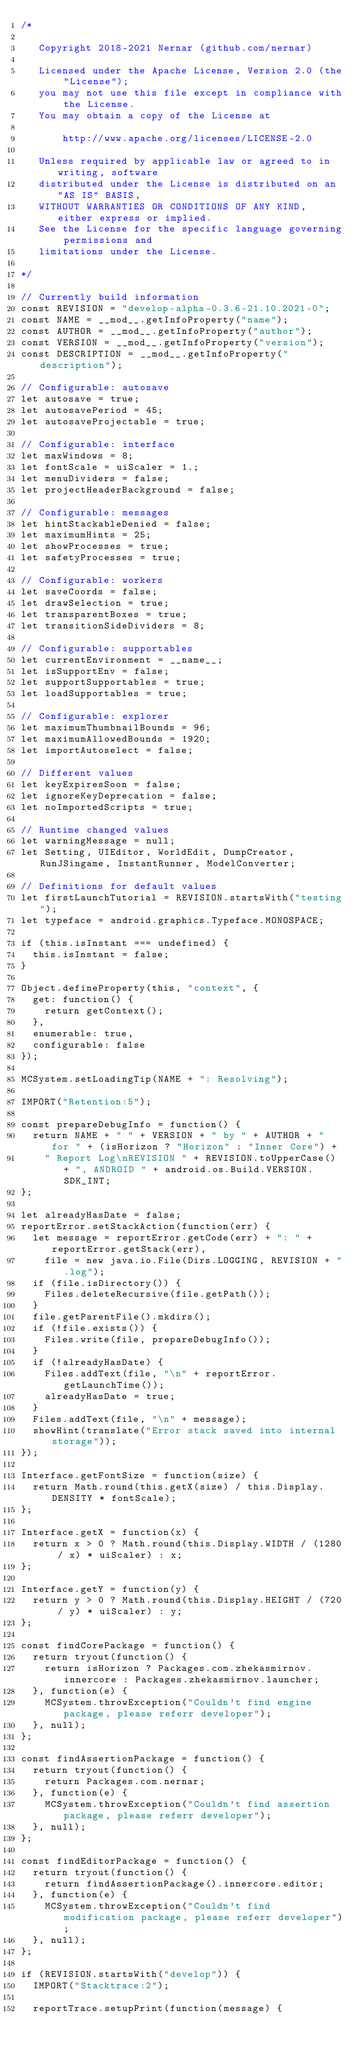<code> <loc_0><loc_0><loc_500><loc_500><_JavaScript_>/*

   Copyright 2018-2021 Nernar (github.com/nernar)
   
   Licensed under the Apache License, Version 2.0 (the "License");
   you may not use this file except in compliance with the License.
   You may obtain a copy of the License at
   
       http://www.apache.org/licenses/LICENSE-2.0
   
   Unless required by applicable law or agreed to in writing, software
   distributed under the License is distributed on an "AS IS" BASIS,
   WITHOUT WARRANTIES OR CONDITIONS OF ANY KIND, either express or implied.
   See the License for the specific language governing permissions and
   limitations under the License.

*/

// Currently build information
const REVISION = "develop-alpha-0.3.6-21.10.2021-0";
const NAME = __mod__.getInfoProperty("name");
const AUTHOR = __mod__.getInfoProperty("author");
const VERSION = __mod__.getInfoProperty("version");
const DESCRIPTION = __mod__.getInfoProperty("description");

// Configurable: autosave
let autosave = true;
let autosavePeriod = 45;
let autosaveProjectable = true;

// Configurable: interface
let maxWindows = 8;
let fontScale = uiScaler = 1.;
let menuDividers = false;
let projectHeaderBackground = false;

// Configurable: messages
let hintStackableDenied = false;
let maximumHints = 25;
let showProcesses = true;
let safetyProcesses = true;

// Configurable: workers
let saveCoords = false;
let drawSelection = true;
let transparentBoxes = true;
let transitionSideDividers = 8;

// Configurable: supportables
let currentEnvironment = __name__;
let isSupportEnv = false;
let supportSupportables = true;
let loadSupportables = true;

// Configurable: explorer
let maximumThumbnailBounds = 96;
let maximumAllowedBounds = 1920;
let importAutoselect = false;

// Different values
let keyExpiresSoon = false;
let ignoreKeyDeprecation = false;
let noImportedScripts = true;

// Runtime changed values
let warningMessage = null;
let Setting, UIEditor, WorldEdit, DumpCreator, RunJSingame, InstantRunner, ModelConverter;

// Definitions for default values
let firstLaunchTutorial = REVISION.startsWith("testing");
let typeface = android.graphics.Typeface.MONOSPACE;

if (this.isInstant === undefined) {
	this.isInstant = false;
}

Object.defineProperty(this, "context", {
	get: function() {
		return getContext();
	},
	enumerable: true,
	configurable: false
});

MCSystem.setLoadingTip(NAME + ": Resolving");

IMPORT("Retention:5");

const prepareDebugInfo = function() {
	return NAME + " " + VERSION + " by " + AUTHOR + " for " + (isHorizon ? "Horizon" : "Inner Core") +
		" Report Log\nREVISION " + REVISION.toUpperCase() + ", ANDROID " + android.os.Build.VERSION.SDK_INT;
};

let alreadyHasDate = false;
reportError.setStackAction(function(err) {
	let message = reportError.getCode(err) + ": " + reportError.getStack(err),
		file = new java.io.File(Dirs.LOGGING, REVISION + ".log");
	if (file.isDirectory()) {
		Files.deleteRecursive(file.getPath());
	}
	file.getParentFile().mkdirs();
	if (!file.exists()) {
		Files.write(file, prepareDebugInfo());
	}
	if (!alreadyHasDate) {
		Files.addText(file, "\n" + reportError.getLaunchTime());
		alreadyHasDate = true;
	}
	Files.addText(file, "\n" + message);
	showHint(translate("Error stack saved into internal storage"));
});

Interface.getFontSize = function(size) {
	return Math.round(this.getX(size) / this.Display.DENSITY * fontScale);
};

Interface.getX = function(x) {
	return x > 0 ? Math.round(this.Display.WIDTH / (1280 / x) * uiScaler) : x;
};

Interface.getY = function(y) {
	return y > 0 ? Math.round(this.Display.HEIGHT / (720 / y) * uiScaler) : y;
};

const findCorePackage = function() {
	return tryout(function() {
		return isHorizon ? Packages.com.zhekasmirnov.innercore : Packages.zhekasmirnov.launcher;
	}, function(e) {
		MCSystem.throwException("Couldn't find engine package, please referr developer");
	}, null);
};

const findAssertionPackage = function() {
	return tryout(function() {
		return Packages.com.nernar;
	}, function(e) {
		MCSystem.throwException("Couldn't find assertion package, please referr developer");
	}, null);
};

const findEditorPackage = function() {
	return tryout(function() {
		return findAssertionPackage().innercore.editor;
	}, function(e) {
		MCSystem.throwException("Couldn't find modification package, please referr developer");
	}, null);
};

if (REVISION.startsWith("develop")) {
	IMPORT("Stacktrace:2");
	
	reportTrace.setupPrint(function(message) {</code> 